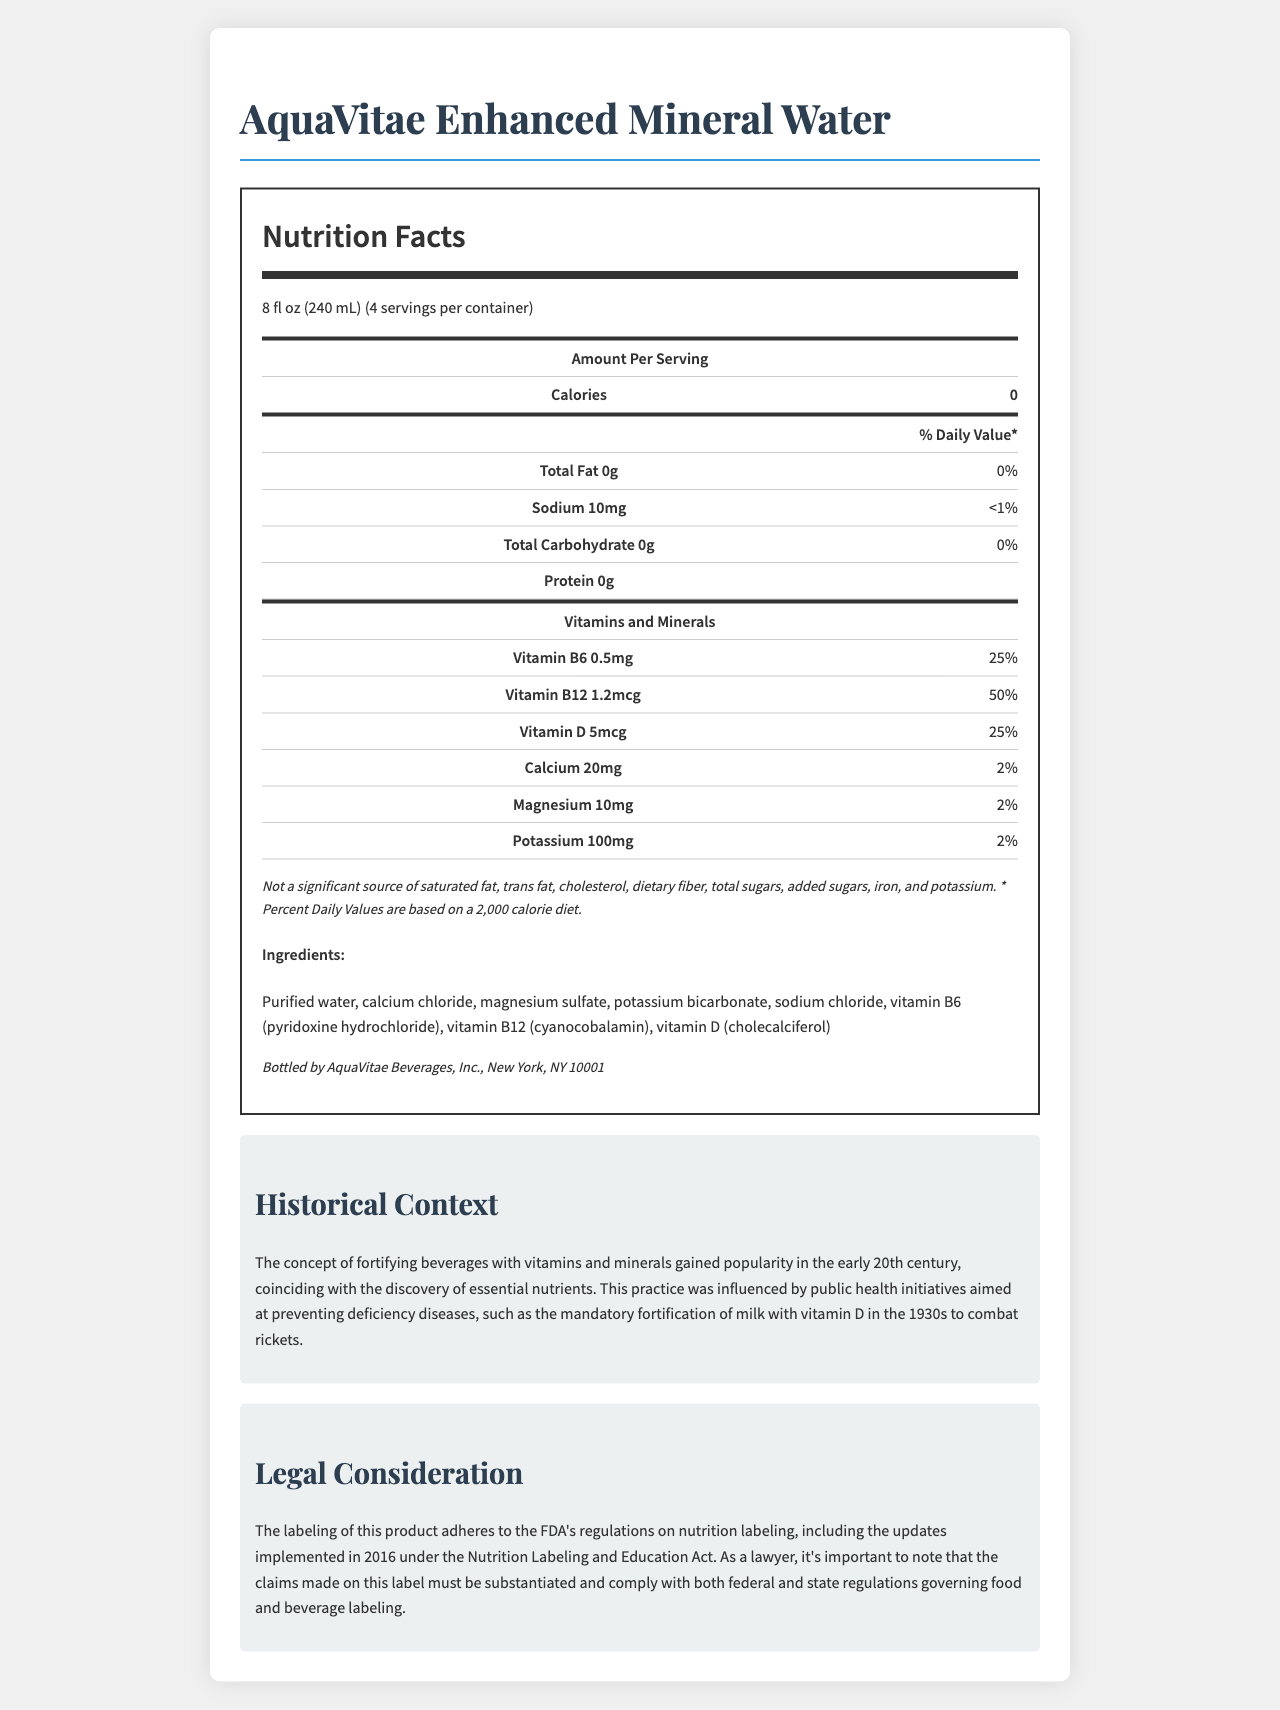who is the manufacturer of AquaVitae Enhanced Mineral Water? The manufacturer information is provided at the bottom of the document, stating it is bottled by AquaVitae Beverages, Inc., New York, NY 10001.
Answer: AquaVitae Beverages, Inc. what is the serving size of AquaVitae Enhanced Mineral Water? The serving size is listed near the top of the document, indicated as "8 fl oz (240 mL)."
Answer: 8 fl oz (240 mL) how many servings are there per container? According to the document, the number of servings per container is "4."
Answer: 4 servings what are the calories per serving? The nutrition label shows the calories per serving as "0."
Answer: 0 calories how much Vitamin B12 is in a serving, and what is its daily value percentage? The nutrition label lists Vitamin B12 as containing 1.2mcg per serving, which is 50% of the daily value.
Answer: 1.2mcg, 50% how much sodium is in a serving, and what is its daily value percentage? According to the nutrition label, sodium content is 10mg per serving, which is less than 1% of the daily value.
Answer: 10mg, <1% what is not a significant source according to the legal disclaimer? The legal disclaimer mentions that these are not significant sources in the AquaVitae Enhanced Mineral Water.
Answer: Saturated fat, trans fat, cholesterol, dietary fiber, total sugars, added sugars, iron, and potassium which vitamin is present in the highest daily value percentage? A. Vitamin B6 B. Vitamin B12 C. Vitamin D Vitamin B12 has a daily value of 50%, which is the highest among the listed vitamins.
Answer: B which mineral has the highest amount per serving? I. Calcium II. Magnesium III. Potassium Potassium has the highest amount per serving at 100mg as compared to Calcium (20mg) and Magnesium (10mg).
Answer: III is AquaVitae Enhanced Mineral Water a good source of total fat? The nutrition label indicates that there is 0g of total fat per serving, making it not a significant source of total fat.
Answer: No what is the main idea of the document? The main idea is to present comprehensive nutritional information along with historical and legal context about the vitamin-fortified bottled water product, AquaVitae Enhanced Mineral Water.
Answer: The document provides detailed nutrition facts, ingredients, historical context, and legal considerations for AquaVitae Enhanced Mineral Water. what is the significance of the 1930s mentioned in the historical context? The historical context section mentions the mandatory fortification of milk with vitamin D in the 1930s as a public health initiative to combat rickets.
Answer: Mandatory fortification of milk with vitamin D to combat rickets. does the document provide the exact source of potassium? The document lists the ingredient as potassium bicarbonate but does not detail the exact source of potassium.
Answer: No what is the relationship between the Nutrition Labeling and Education Act and the document? The legal consideration section states that this product's labeling complies with the Nutrition Labeling and Education Act's regulations updated in 2016 by the FDA.
Answer: The document's labeling adheres to the FDA's regulations under the Nutrition Labeling and Education Act, updated in 2016. is AquaVitae Enhanced Mineral Water a single-serving product? The document indicates that the product contains 4 servings per container, making it a multi-serving product.
Answer: No 